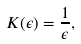Convert formula to latex. <formula><loc_0><loc_0><loc_500><loc_500>K ( \epsilon ) = \frac { 1 } { \epsilon } ,</formula> 